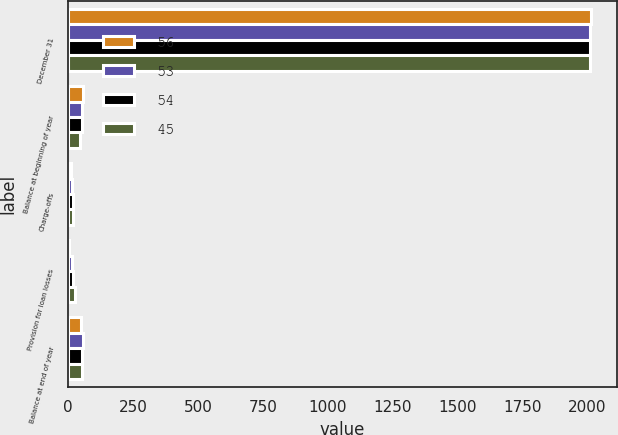Convert chart. <chart><loc_0><loc_0><loc_500><loc_500><stacked_bar_chart><ecel><fcel>December 31<fcel>Balance at beginning of year<fcel>Charge-offs<fcel>Provision for loan losses<fcel>Balance at end of year<nl><fcel>56<fcel>2013<fcel>56<fcel>11<fcel>1<fcel>48<nl><fcel>53<fcel>2012<fcel>54<fcel>16<fcel>16<fcel>56<nl><fcel>54<fcel>2011<fcel>53<fcel>19<fcel>18<fcel>54<nl><fcel>45<fcel>2010<fcel>45<fcel>20<fcel>27<fcel>53<nl></chart> 